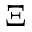Convert formula to latex. <formula><loc_0><loc_0><loc_500><loc_500>\Xi</formula> 